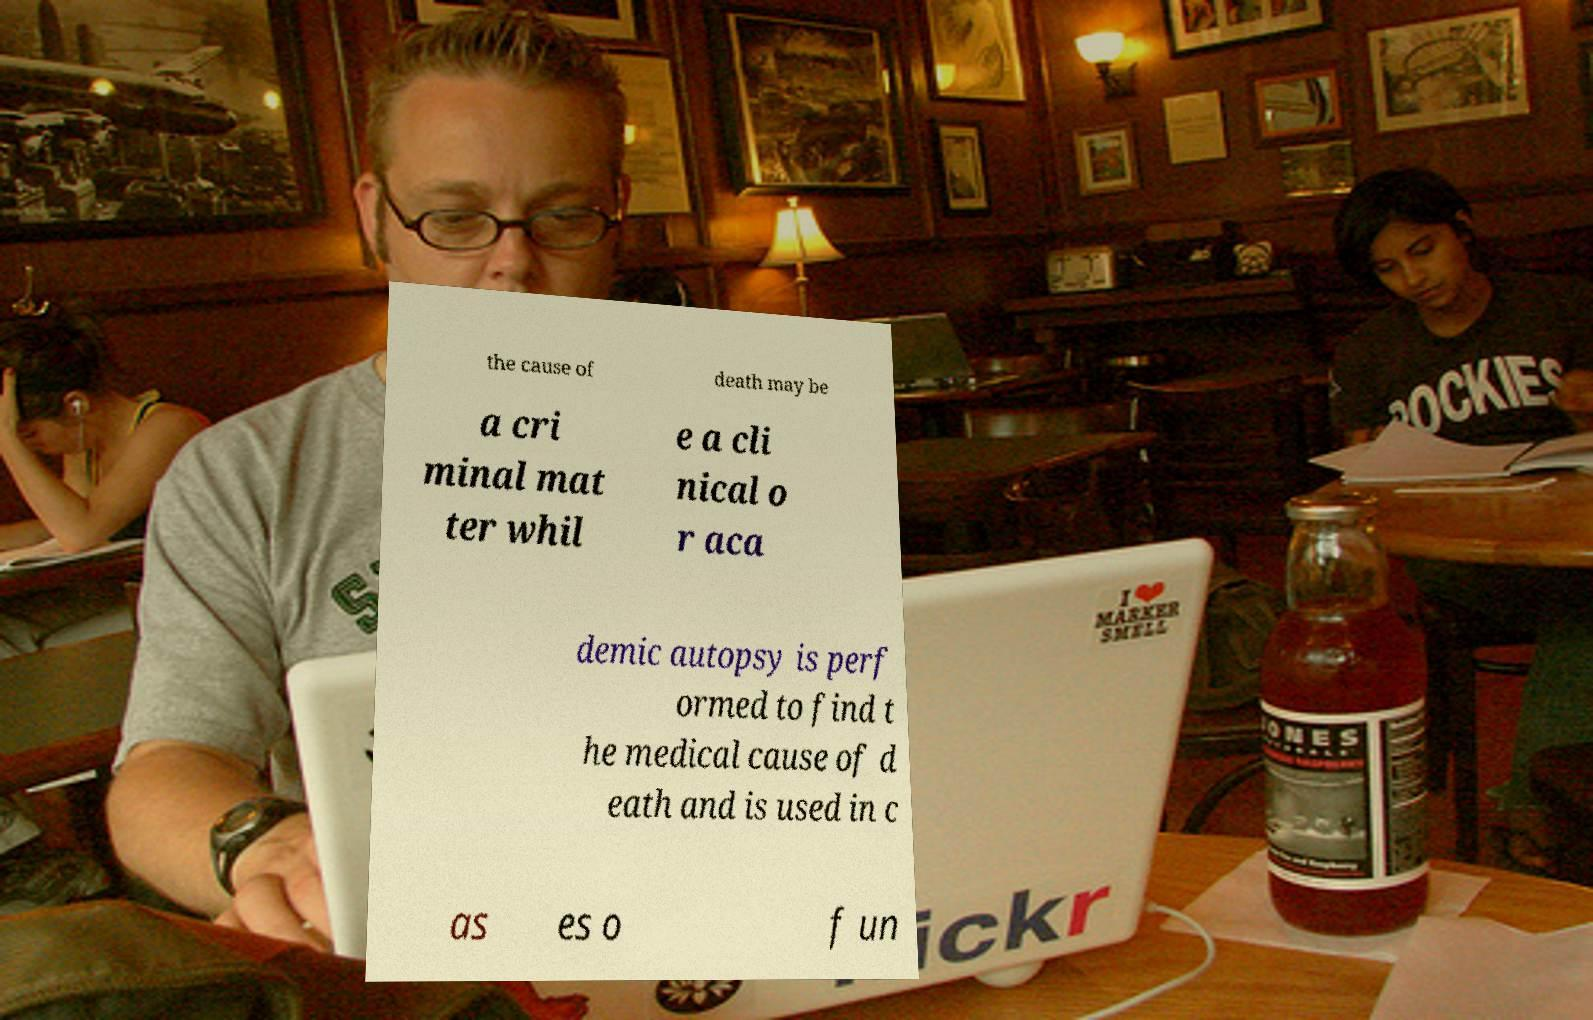Can you accurately transcribe the text from the provided image for me? the cause of death may be a cri minal mat ter whil e a cli nical o r aca demic autopsy is perf ormed to find t he medical cause of d eath and is used in c as es o f un 